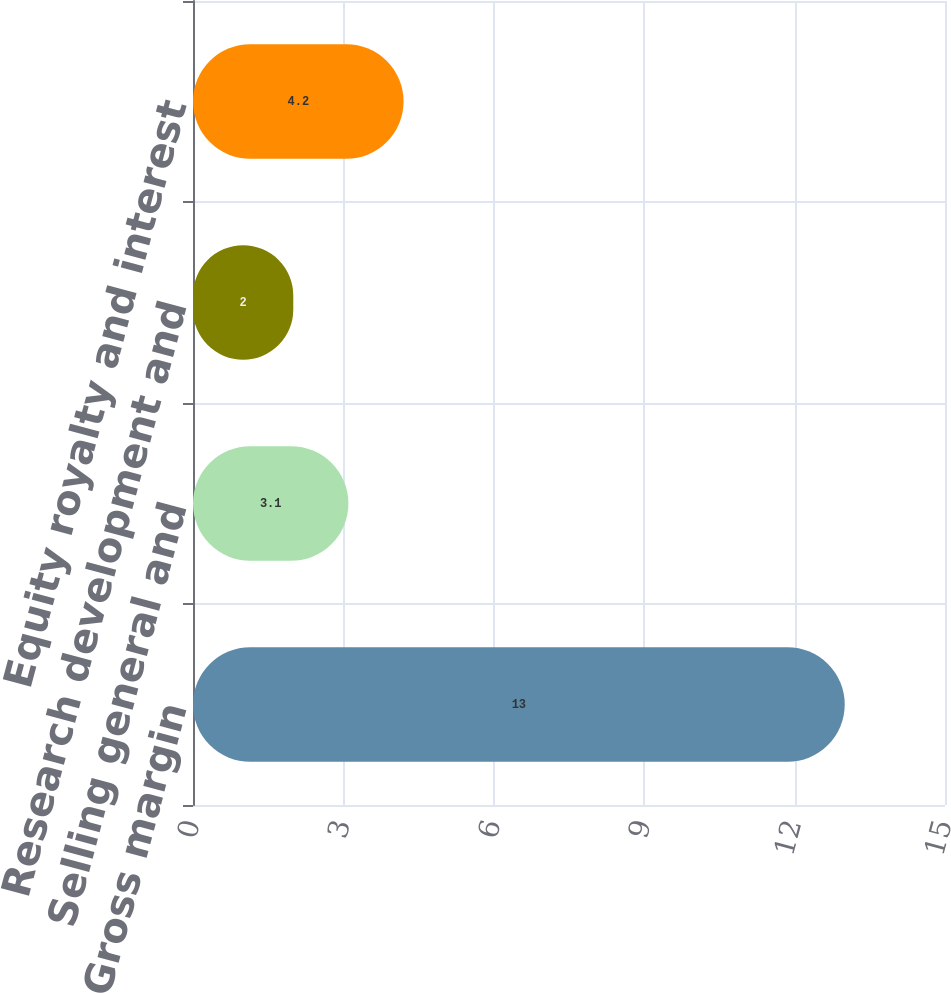<chart> <loc_0><loc_0><loc_500><loc_500><bar_chart><fcel>Gross margin<fcel>Selling general and<fcel>Research development and<fcel>Equity royalty and interest<nl><fcel>13<fcel>3.1<fcel>2<fcel>4.2<nl></chart> 